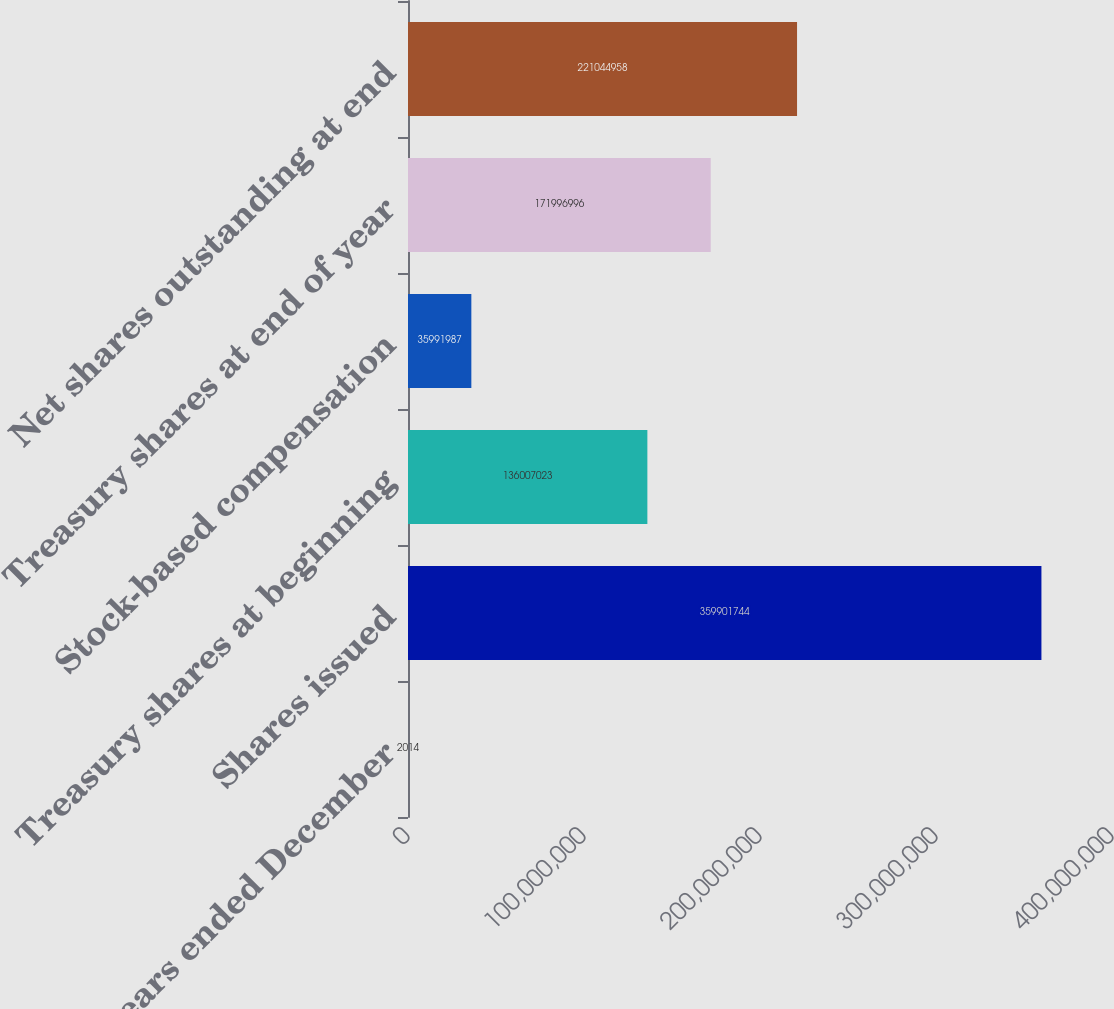Convert chart. <chart><loc_0><loc_0><loc_500><loc_500><bar_chart><fcel>For the years ended December<fcel>Shares issued<fcel>Treasury shares at beginning<fcel>Stock-based compensation<fcel>Treasury shares at end of year<fcel>Net shares outstanding at end<nl><fcel>2014<fcel>3.59902e+08<fcel>1.36007e+08<fcel>3.5992e+07<fcel>1.71997e+08<fcel>2.21045e+08<nl></chart> 